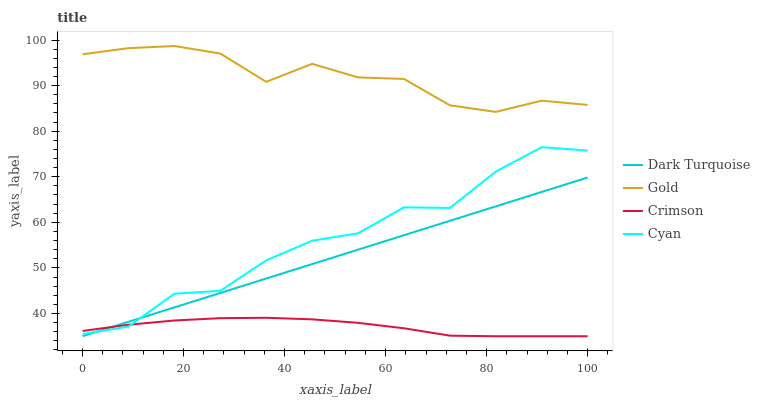Does Dark Turquoise have the minimum area under the curve?
Answer yes or no. No. Does Dark Turquoise have the maximum area under the curve?
Answer yes or no. No. Is Gold the smoothest?
Answer yes or no. No. Is Gold the roughest?
Answer yes or no. No. Does Gold have the lowest value?
Answer yes or no. No. Does Dark Turquoise have the highest value?
Answer yes or no. No. Is Crimson less than Gold?
Answer yes or no. Yes. Is Gold greater than Dark Turquoise?
Answer yes or no. Yes. Does Crimson intersect Gold?
Answer yes or no. No. 